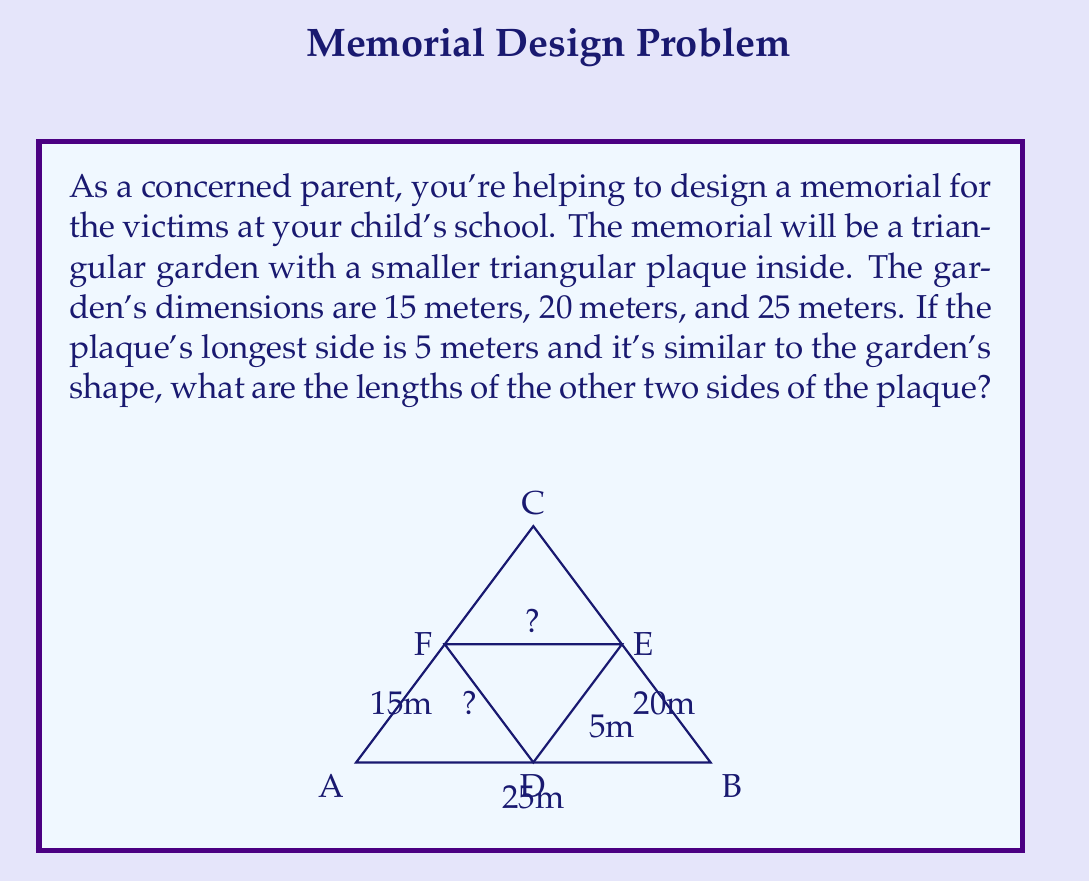Help me with this question. Let's approach this step-by-step using the properties of similar triangles:

1) In similar triangles, the ratio of corresponding sides is constant. Let's call this ratio $r$. We can find $r$ by comparing the known sides:

   $r = \frac{\text{plaque side}}{\text{garden side}} = \frac{5}{25} = \frac{1}{5}$

2) Now we can use this ratio to find the other sides of the plaque:

   For the side corresponding to the 20m garden side:
   $$ \frac{x}{20} = \frac{1}{5} $$
   $$ x = 20 \cdot \frac{1}{5} = 4\text{ meters} $$

   For the side corresponding to the 15m garden side:
   $$ \frac{y}{15} = \frac{1}{5} $$
   $$ y = 15 \cdot \frac{1}{5} = 3\text{ meters} $$

3) We can verify our answer using the Pythagorean theorem:
   $$ 3^2 + 4^2 = 5^2 $$
   $$ 9 + 16 = 25 $$

This confirms that our calculations are correct.
Answer: The other two sides of the plaque are 4 meters and 3 meters. 